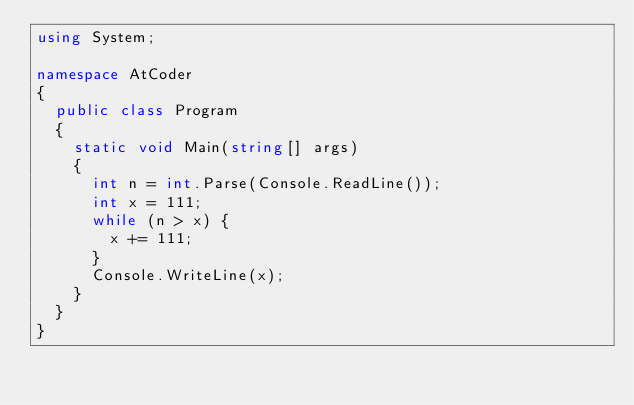Convert code to text. <code><loc_0><loc_0><loc_500><loc_500><_C#_>using System;

namespace AtCoder
{
	public class Program
	{
		static void Main(string[] args)
		{
			int n = int.Parse(Console.ReadLine());
			int x = 111;
			while (n > x) {
				x += 111;
			}
			Console.WriteLine(x);
		}
	}
}
</code> 